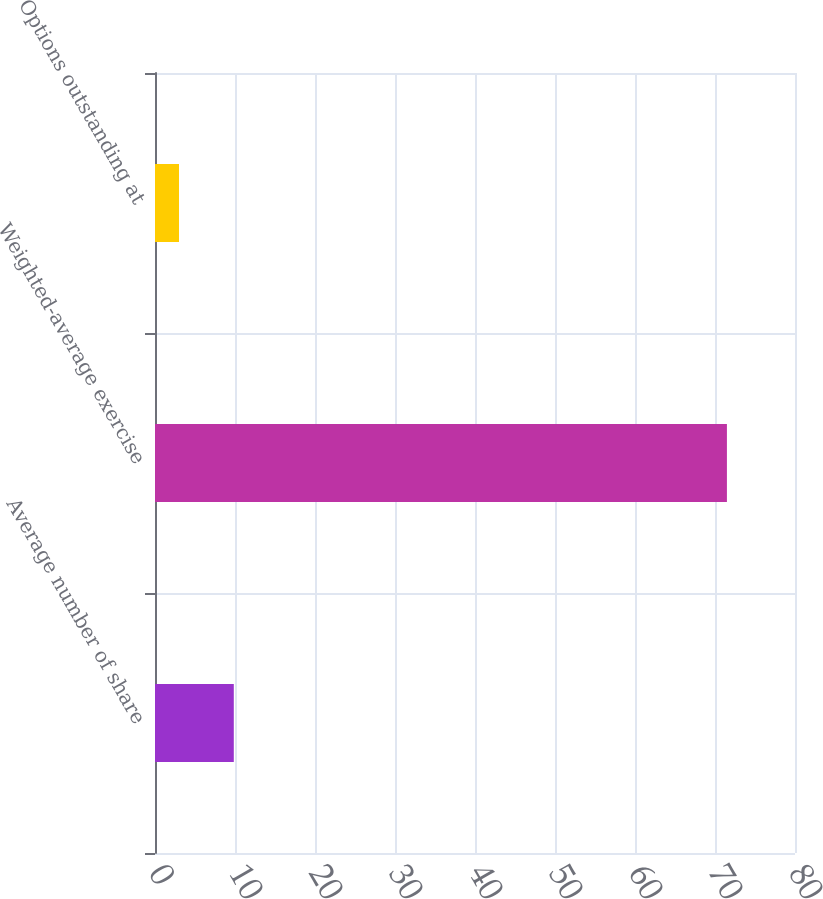Convert chart. <chart><loc_0><loc_0><loc_500><loc_500><bar_chart><fcel>Average number of share<fcel>Weighted-average exercise<fcel>Options outstanding at<nl><fcel>9.85<fcel>71.49<fcel>3<nl></chart> 